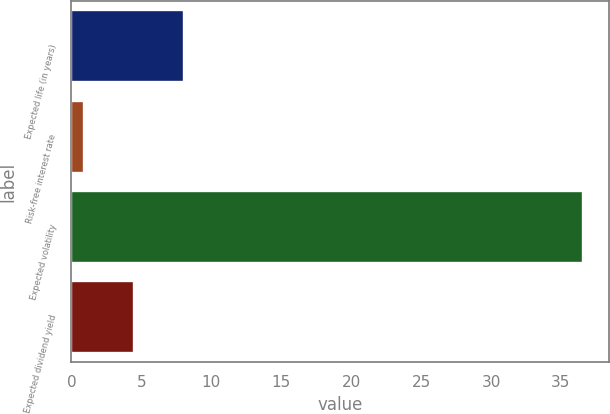<chart> <loc_0><loc_0><loc_500><loc_500><bar_chart><fcel>Expected life (in years)<fcel>Risk-free interest rate<fcel>Expected volatility<fcel>Expected dividend yield<nl><fcel>8.04<fcel>0.9<fcel>36.6<fcel>4.47<nl></chart> 